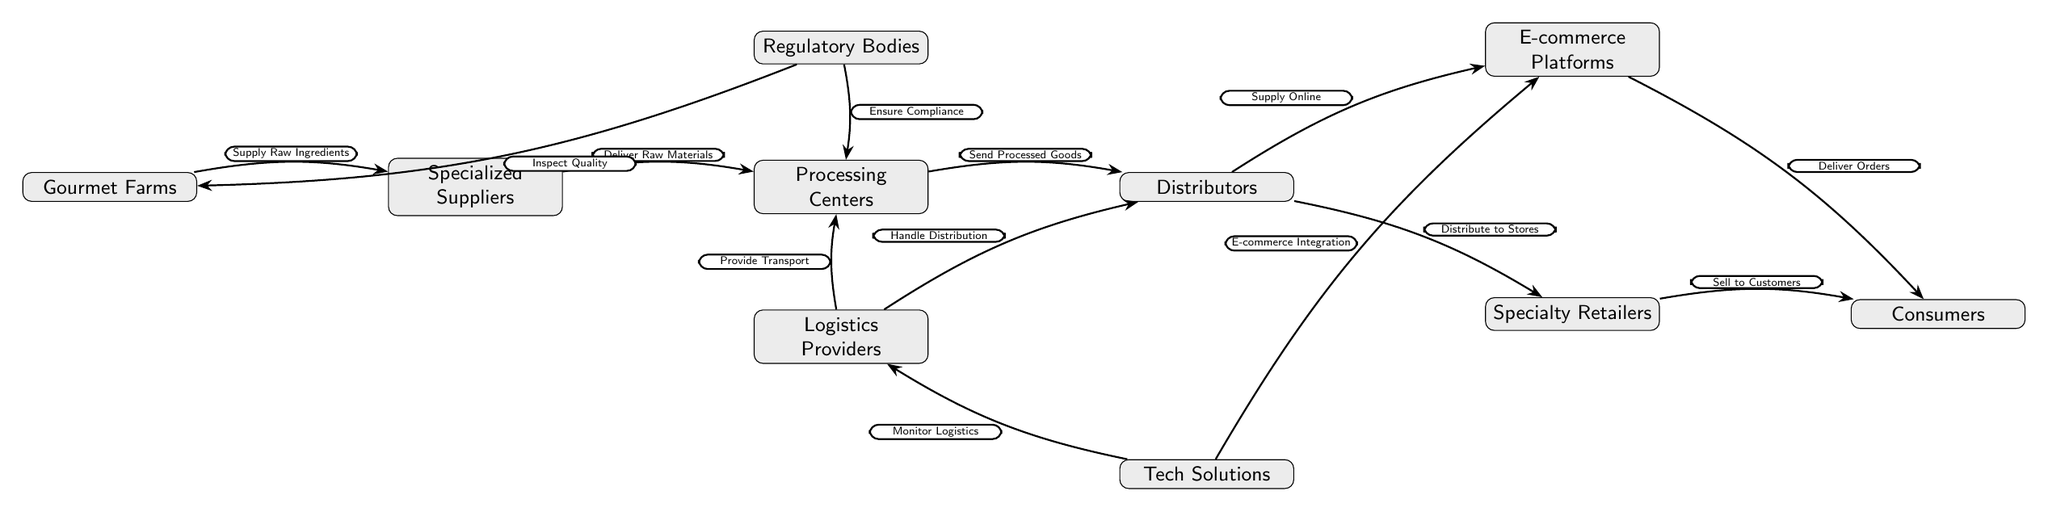What is the starting point of the supply chain? The starting point, or first node in the diagram, is "Gourmet Farms," which is where the supply of raw ingredients originates.
Answer: Gourmet Farms How many nodes are present in the diagram? Counting all the unique entities and categories displayed in the diagram, there are a total of 9 nodes that represent different levels and roles in the supply chain.
Answer: 9 What do Regulatory Bodies inspect? Regulatory Bodies are responsible for the task labeled "Inspect Quality," which indicates their role in ensuring the quality of products at the farms stage.
Answer: Quality Who handles distribution for the distributors? The node labeled "Logistics Providers" is shown to be responsible for handling distribution, as indicated by the edge pointing towards the distributors with the label "Handle Distribution."
Answer: Logistics Providers Which node connects to both E-commerce Platforms and Specialty Retailers? The "Distributors" node connects to both E-commerce Platforms and Specialty Retailers, as indicated by the outgoing arrows labeled "Supply Online" and "Distribute to Stores."
Answer: Distributors What is the relationship between Processing Centers and Regulatory Bodies? The relationship illustrated is that the Regulatory Bodies "Ensure Compliance" with the processing activities occurring within the Processing Centers, which means they govern the adherence to rules at this stage.
Answer: Ensure Compliance What do Technology Solutions provide to Logistics Providers? The Technology Solutions provide "Monitor Logistics" to Logistics Providers, indicating that they assist with tracking and managing the logistics aspect of the supply chain.
Answer: Monitor Logistics How do consumers receive products from E-commerce Platforms? The flow indicates that consumers receive products as a result of the action labeled "Deliver Orders," which signifies the process of fulfilling online orders.
Answer: Deliver Orders What is the last node in the food chain? The last node in the diagram, indicating the end of the supply chain, is "Consumers," who ultimately receive the gourmet products after the preceding stages.
Answer: Consumers 